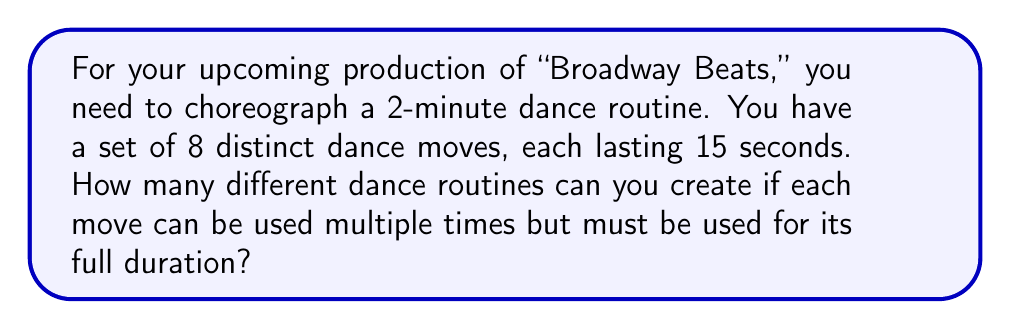Provide a solution to this math problem. Let's approach this step-by-step:

1) First, we need to calculate how many 15-second segments are in a 2-minute routine:
   $$ \text{Number of segments} = \frac{120 \text{ seconds}}{15 \text{ seconds per move}} = 8 \text{ segments} $$

2) Now, for each of these 8 segments, we have 8 possible moves to choose from. This is because:
   - Each move can be used multiple times (with replacement)
   - The order matters (sequence is important in dance)

3) This scenario is a classic example of the multiplication principle in combinatorics. When we have n independent events, each with m possible outcomes, the total number of possible outcomes is $m^n$.

4) In this case:
   - n = number of segments = 8
   - m = number of possible moves for each segment = 8

5) Therefore, the total number of possible dance routines is:

   $$ \text{Total routines} = 8^8 = 16,777,216 $$

This means you have over 16 million possible unique dance routines to choose from!
Answer: 16,777,216 possible dance routines 